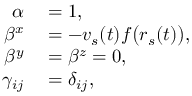<formula> <loc_0><loc_0><loc_500><loc_500>\begin{array} { r l } { \alpha } & = 1 , } \\ { \beta ^ { x } } & = - v _ { s } ( t ) f { \left ( } r _ { s } ( t ) { \right ) } , } \\ { \beta ^ { y } } & = \beta ^ { z } = 0 , } \\ { \gamma _ { i j } } & = \delta _ { i j } , } \end{array}</formula> 